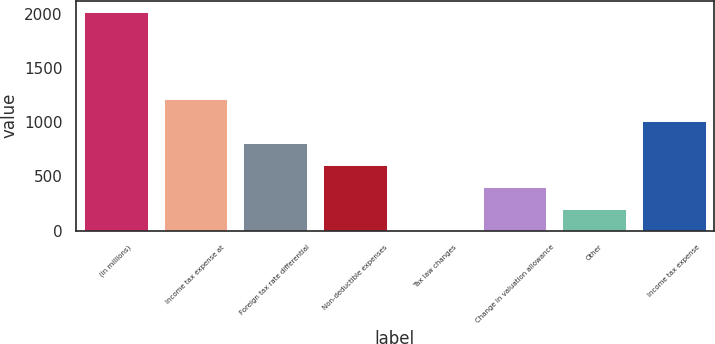Convert chart. <chart><loc_0><loc_0><loc_500><loc_500><bar_chart><fcel>(in millions)<fcel>Income tax expense at<fcel>Foreign tax rate differential<fcel>Non-deductible expenses<fcel>Tax law changes<fcel>Change in valuation allowance<fcel>Other<fcel>Income tax expense<nl><fcel>2017<fcel>1210.48<fcel>807.22<fcel>605.59<fcel>0.7<fcel>403.96<fcel>202.33<fcel>1008.85<nl></chart> 